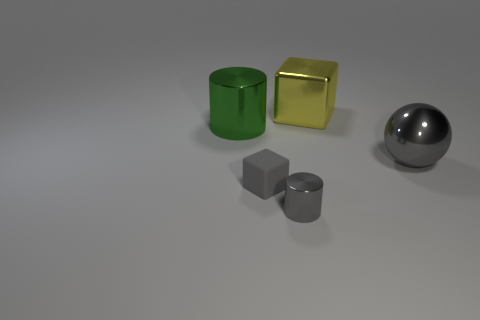Subtract all yellow balls. Subtract all purple cylinders. How many balls are left? 1 Add 1 yellow shiny balls. How many objects exist? 6 Subtract all balls. How many objects are left? 4 Add 5 cyan shiny cylinders. How many cyan shiny cylinders exist? 5 Subtract 1 gray cylinders. How many objects are left? 4 Subtract all large green cylinders. Subtract all big yellow cylinders. How many objects are left? 4 Add 1 large spheres. How many large spheres are left? 2 